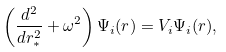Convert formula to latex. <formula><loc_0><loc_0><loc_500><loc_500>\left ( \frac { d ^ { 2 } } { d r _ { \ast } ^ { 2 } } + \omega ^ { 2 } \right ) \Psi _ { i } ( r ) = V _ { i } \Psi _ { i } ( r ) ,</formula> 